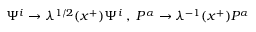<formula> <loc_0><loc_0><loc_500><loc_500>\Psi ^ { i } \rightarrow \lambda ^ { 1 / 2 } ( x ^ { + } ) \Psi ^ { i } \, , \, P ^ { \alpha } \rightarrow \lambda ^ { - 1 } ( x ^ { + } ) P ^ { \alpha }</formula> 